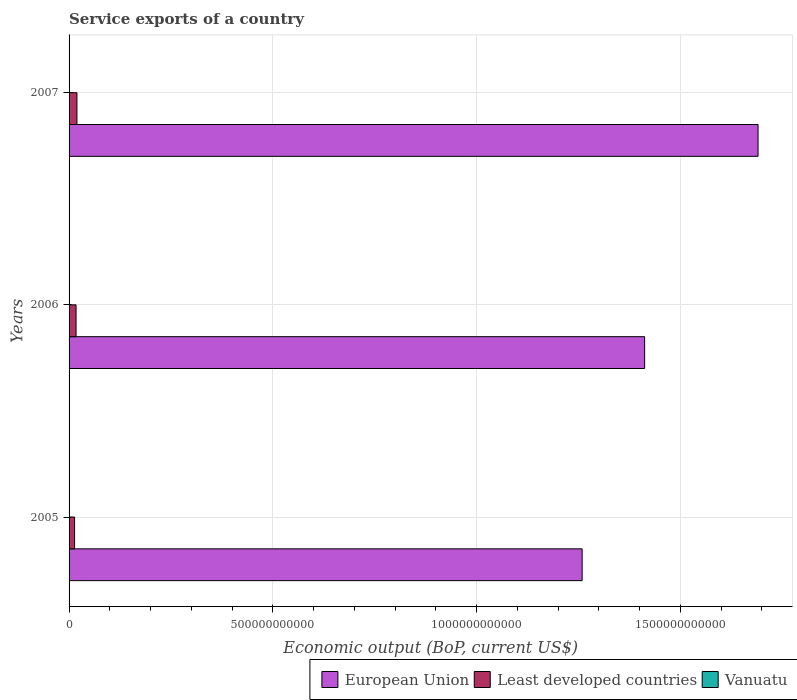How many different coloured bars are there?
Provide a succinct answer. 3. How many groups of bars are there?
Your response must be concise. 3. Are the number of bars per tick equal to the number of legend labels?
Provide a short and direct response. Yes. How many bars are there on the 1st tick from the top?
Give a very brief answer. 3. How many bars are there on the 1st tick from the bottom?
Provide a succinct answer. 3. What is the service exports in Least developed countries in 2005?
Give a very brief answer. 1.35e+1. Across all years, what is the maximum service exports in Least developed countries?
Give a very brief answer. 1.93e+1. Across all years, what is the minimum service exports in European Union?
Keep it short and to the point. 1.26e+12. What is the total service exports in Least developed countries in the graph?
Provide a short and direct response. 5.00e+1. What is the difference between the service exports in Least developed countries in 2005 and that in 2006?
Your answer should be compact. -3.64e+09. What is the difference between the service exports in Vanuatu in 2006 and the service exports in Least developed countries in 2007?
Your answer should be compact. -1.92e+1. What is the average service exports in Vanuatu per year?
Offer a very short reply. 1.57e+08. In the year 2005, what is the difference between the service exports in European Union and service exports in Least developed countries?
Your answer should be very brief. 1.25e+12. What is the ratio of the service exports in Vanuatu in 2006 to that in 2007?
Keep it short and to the point. 0.78. Is the service exports in Vanuatu in 2006 less than that in 2007?
Offer a very short reply. Yes. Is the difference between the service exports in European Union in 2005 and 2007 greater than the difference between the service exports in Least developed countries in 2005 and 2007?
Give a very brief answer. No. What is the difference between the highest and the second highest service exports in Least developed countries?
Give a very brief answer. 2.13e+09. What is the difference between the highest and the lowest service exports in Least developed countries?
Your answer should be very brief. 5.77e+09. In how many years, is the service exports in European Union greater than the average service exports in European Union taken over all years?
Provide a succinct answer. 1. Is the sum of the service exports in Vanuatu in 2005 and 2007 greater than the maximum service exports in Least developed countries across all years?
Provide a short and direct response. No. What does the 1st bar from the top in 2007 represents?
Provide a short and direct response. Vanuatu. How many years are there in the graph?
Ensure brevity in your answer.  3. What is the difference between two consecutive major ticks on the X-axis?
Ensure brevity in your answer.  5.00e+11. Are the values on the major ticks of X-axis written in scientific E-notation?
Make the answer very short. No. Does the graph contain grids?
Your response must be concise. Yes. How many legend labels are there?
Give a very brief answer. 3. What is the title of the graph?
Offer a terse response. Service exports of a country. What is the label or title of the X-axis?
Make the answer very short. Economic output (BoP, current US$). What is the Economic output (BoP, current US$) in European Union in 2005?
Ensure brevity in your answer.  1.26e+12. What is the Economic output (BoP, current US$) of Least developed countries in 2005?
Provide a short and direct response. 1.35e+1. What is the Economic output (BoP, current US$) of Vanuatu in 2005?
Offer a terse response. 1.39e+08. What is the Economic output (BoP, current US$) of European Union in 2006?
Your response must be concise. 1.41e+12. What is the Economic output (BoP, current US$) of Least developed countries in 2006?
Provide a succinct answer. 1.72e+1. What is the Economic output (BoP, current US$) of Vanuatu in 2006?
Your response must be concise. 1.46e+08. What is the Economic output (BoP, current US$) in European Union in 2007?
Ensure brevity in your answer.  1.69e+12. What is the Economic output (BoP, current US$) in Least developed countries in 2007?
Give a very brief answer. 1.93e+1. What is the Economic output (BoP, current US$) in Vanuatu in 2007?
Provide a short and direct response. 1.86e+08. Across all years, what is the maximum Economic output (BoP, current US$) in European Union?
Keep it short and to the point. 1.69e+12. Across all years, what is the maximum Economic output (BoP, current US$) in Least developed countries?
Give a very brief answer. 1.93e+1. Across all years, what is the maximum Economic output (BoP, current US$) in Vanuatu?
Make the answer very short. 1.86e+08. Across all years, what is the minimum Economic output (BoP, current US$) in European Union?
Your answer should be very brief. 1.26e+12. Across all years, what is the minimum Economic output (BoP, current US$) of Least developed countries?
Provide a short and direct response. 1.35e+1. Across all years, what is the minimum Economic output (BoP, current US$) of Vanuatu?
Make the answer very short. 1.39e+08. What is the total Economic output (BoP, current US$) in European Union in the graph?
Offer a very short reply. 4.36e+12. What is the total Economic output (BoP, current US$) of Least developed countries in the graph?
Your answer should be very brief. 5.00e+1. What is the total Economic output (BoP, current US$) of Vanuatu in the graph?
Keep it short and to the point. 4.71e+08. What is the difference between the Economic output (BoP, current US$) of European Union in 2005 and that in 2006?
Keep it short and to the point. -1.53e+11. What is the difference between the Economic output (BoP, current US$) of Least developed countries in 2005 and that in 2006?
Give a very brief answer. -3.64e+09. What is the difference between the Economic output (BoP, current US$) of Vanuatu in 2005 and that in 2006?
Make the answer very short. -6.97e+06. What is the difference between the Economic output (BoP, current US$) of European Union in 2005 and that in 2007?
Offer a terse response. -4.32e+11. What is the difference between the Economic output (BoP, current US$) of Least developed countries in 2005 and that in 2007?
Keep it short and to the point. -5.77e+09. What is the difference between the Economic output (BoP, current US$) in Vanuatu in 2005 and that in 2007?
Give a very brief answer. -4.71e+07. What is the difference between the Economic output (BoP, current US$) of European Union in 2006 and that in 2007?
Offer a terse response. -2.78e+11. What is the difference between the Economic output (BoP, current US$) of Least developed countries in 2006 and that in 2007?
Provide a short and direct response. -2.13e+09. What is the difference between the Economic output (BoP, current US$) in Vanuatu in 2006 and that in 2007?
Offer a very short reply. -4.01e+07. What is the difference between the Economic output (BoP, current US$) of European Union in 2005 and the Economic output (BoP, current US$) of Least developed countries in 2006?
Your response must be concise. 1.24e+12. What is the difference between the Economic output (BoP, current US$) of European Union in 2005 and the Economic output (BoP, current US$) of Vanuatu in 2006?
Provide a short and direct response. 1.26e+12. What is the difference between the Economic output (BoP, current US$) of Least developed countries in 2005 and the Economic output (BoP, current US$) of Vanuatu in 2006?
Your answer should be compact. 1.34e+1. What is the difference between the Economic output (BoP, current US$) of European Union in 2005 and the Economic output (BoP, current US$) of Least developed countries in 2007?
Provide a short and direct response. 1.24e+12. What is the difference between the Economic output (BoP, current US$) of European Union in 2005 and the Economic output (BoP, current US$) of Vanuatu in 2007?
Your answer should be compact. 1.26e+12. What is the difference between the Economic output (BoP, current US$) of Least developed countries in 2005 and the Economic output (BoP, current US$) of Vanuatu in 2007?
Provide a short and direct response. 1.33e+1. What is the difference between the Economic output (BoP, current US$) in European Union in 2006 and the Economic output (BoP, current US$) in Least developed countries in 2007?
Offer a very short reply. 1.39e+12. What is the difference between the Economic output (BoP, current US$) in European Union in 2006 and the Economic output (BoP, current US$) in Vanuatu in 2007?
Provide a short and direct response. 1.41e+12. What is the difference between the Economic output (BoP, current US$) of Least developed countries in 2006 and the Economic output (BoP, current US$) of Vanuatu in 2007?
Offer a terse response. 1.70e+1. What is the average Economic output (BoP, current US$) in European Union per year?
Offer a terse response. 1.45e+12. What is the average Economic output (BoP, current US$) in Least developed countries per year?
Your response must be concise. 1.67e+1. What is the average Economic output (BoP, current US$) in Vanuatu per year?
Keep it short and to the point. 1.57e+08. In the year 2005, what is the difference between the Economic output (BoP, current US$) in European Union and Economic output (BoP, current US$) in Least developed countries?
Your answer should be compact. 1.25e+12. In the year 2005, what is the difference between the Economic output (BoP, current US$) of European Union and Economic output (BoP, current US$) of Vanuatu?
Ensure brevity in your answer.  1.26e+12. In the year 2005, what is the difference between the Economic output (BoP, current US$) of Least developed countries and Economic output (BoP, current US$) of Vanuatu?
Provide a short and direct response. 1.34e+1. In the year 2006, what is the difference between the Economic output (BoP, current US$) in European Union and Economic output (BoP, current US$) in Least developed countries?
Ensure brevity in your answer.  1.40e+12. In the year 2006, what is the difference between the Economic output (BoP, current US$) in European Union and Economic output (BoP, current US$) in Vanuatu?
Make the answer very short. 1.41e+12. In the year 2006, what is the difference between the Economic output (BoP, current US$) in Least developed countries and Economic output (BoP, current US$) in Vanuatu?
Your answer should be compact. 1.70e+1. In the year 2007, what is the difference between the Economic output (BoP, current US$) in European Union and Economic output (BoP, current US$) in Least developed countries?
Make the answer very short. 1.67e+12. In the year 2007, what is the difference between the Economic output (BoP, current US$) in European Union and Economic output (BoP, current US$) in Vanuatu?
Your response must be concise. 1.69e+12. In the year 2007, what is the difference between the Economic output (BoP, current US$) in Least developed countries and Economic output (BoP, current US$) in Vanuatu?
Provide a succinct answer. 1.91e+1. What is the ratio of the Economic output (BoP, current US$) of European Union in 2005 to that in 2006?
Your answer should be compact. 0.89. What is the ratio of the Economic output (BoP, current US$) of Least developed countries in 2005 to that in 2006?
Give a very brief answer. 0.79. What is the ratio of the Economic output (BoP, current US$) of Vanuatu in 2005 to that in 2006?
Your answer should be very brief. 0.95. What is the ratio of the Economic output (BoP, current US$) in European Union in 2005 to that in 2007?
Provide a succinct answer. 0.74. What is the ratio of the Economic output (BoP, current US$) of Least developed countries in 2005 to that in 2007?
Keep it short and to the point. 0.7. What is the ratio of the Economic output (BoP, current US$) of Vanuatu in 2005 to that in 2007?
Make the answer very short. 0.75. What is the ratio of the Economic output (BoP, current US$) of European Union in 2006 to that in 2007?
Provide a short and direct response. 0.84. What is the ratio of the Economic output (BoP, current US$) in Least developed countries in 2006 to that in 2007?
Ensure brevity in your answer.  0.89. What is the ratio of the Economic output (BoP, current US$) in Vanuatu in 2006 to that in 2007?
Provide a short and direct response. 0.78. What is the difference between the highest and the second highest Economic output (BoP, current US$) of European Union?
Give a very brief answer. 2.78e+11. What is the difference between the highest and the second highest Economic output (BoP, current US$) of Least developed countries?
Offer a very short reply. 2.13e+09. What is the difference between the highest and the second highest Economic output (BoP, current US$) of Vanuatu?
Your answer should be compact. 4.01e+07. What is the difference between the highest and the lowest Economic output (BoP, current US$) in European Union?
Offer a terse response. 4.32e+11. What is the difference between the highest and the lowest Economic output (BoP, current US$) in Least developed countries?
Provide a succinct answer. 5.77e+09. What is the difference between the highest and the lowest Economic output (BoP, current US$) in Vanuatu?
Your answer should be very brief. 4.71e+07. 